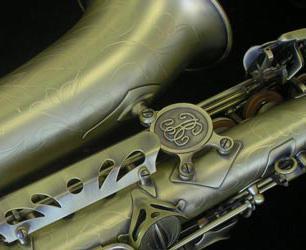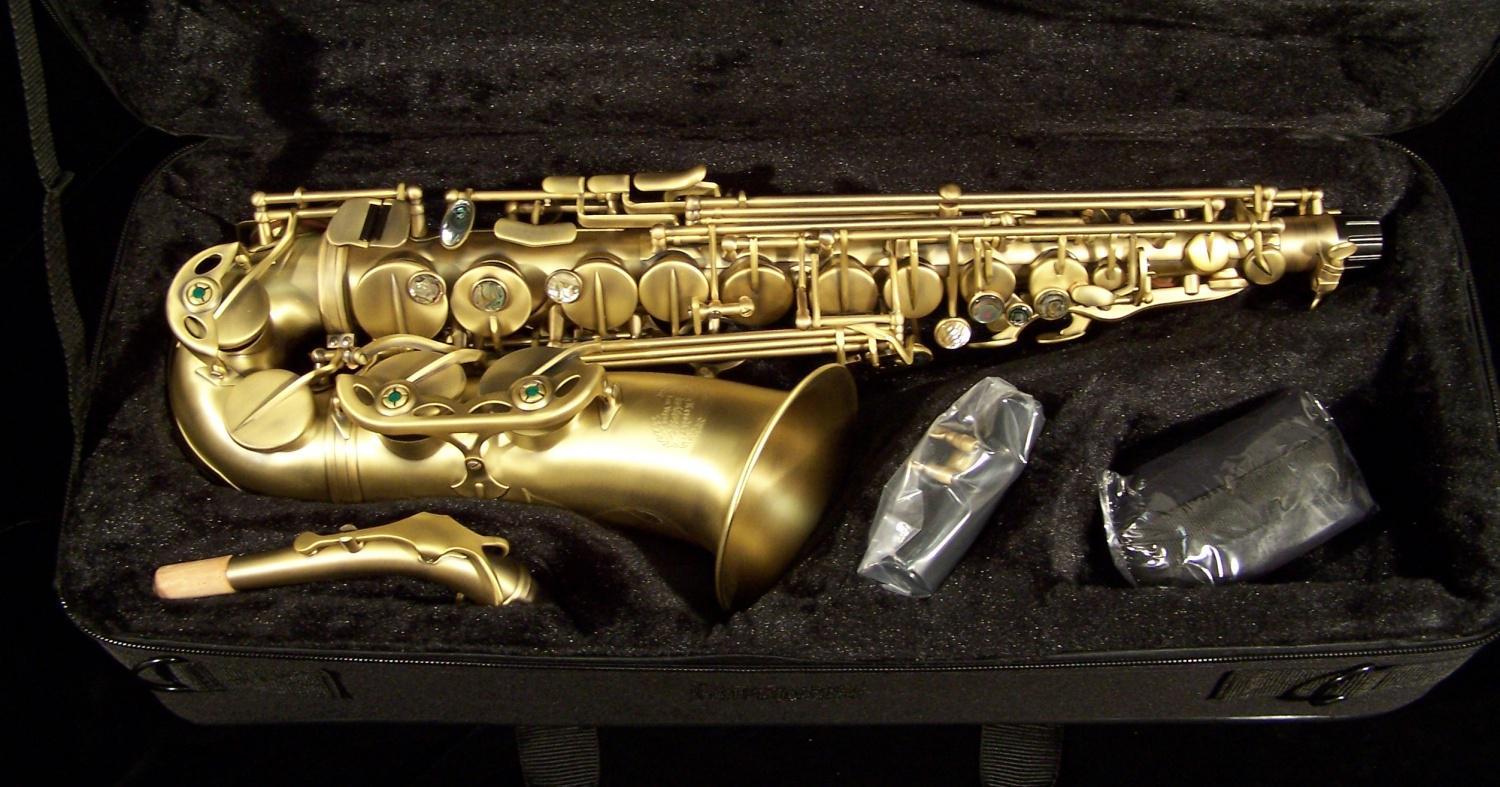The first image is the image on the left, the second image is the image on the right. For the images shown, is this caption "One sax is laying exactly horizontally." true? Answer yes or no. Yes. The first image is the image on the left, the second image is the image on the right. Given the left and right images, does the statement "The combined images include an open case, a saxophone displayed horizontally, and a saxophone displayed diagonally." hold true? Answer yes or no. Yes. 